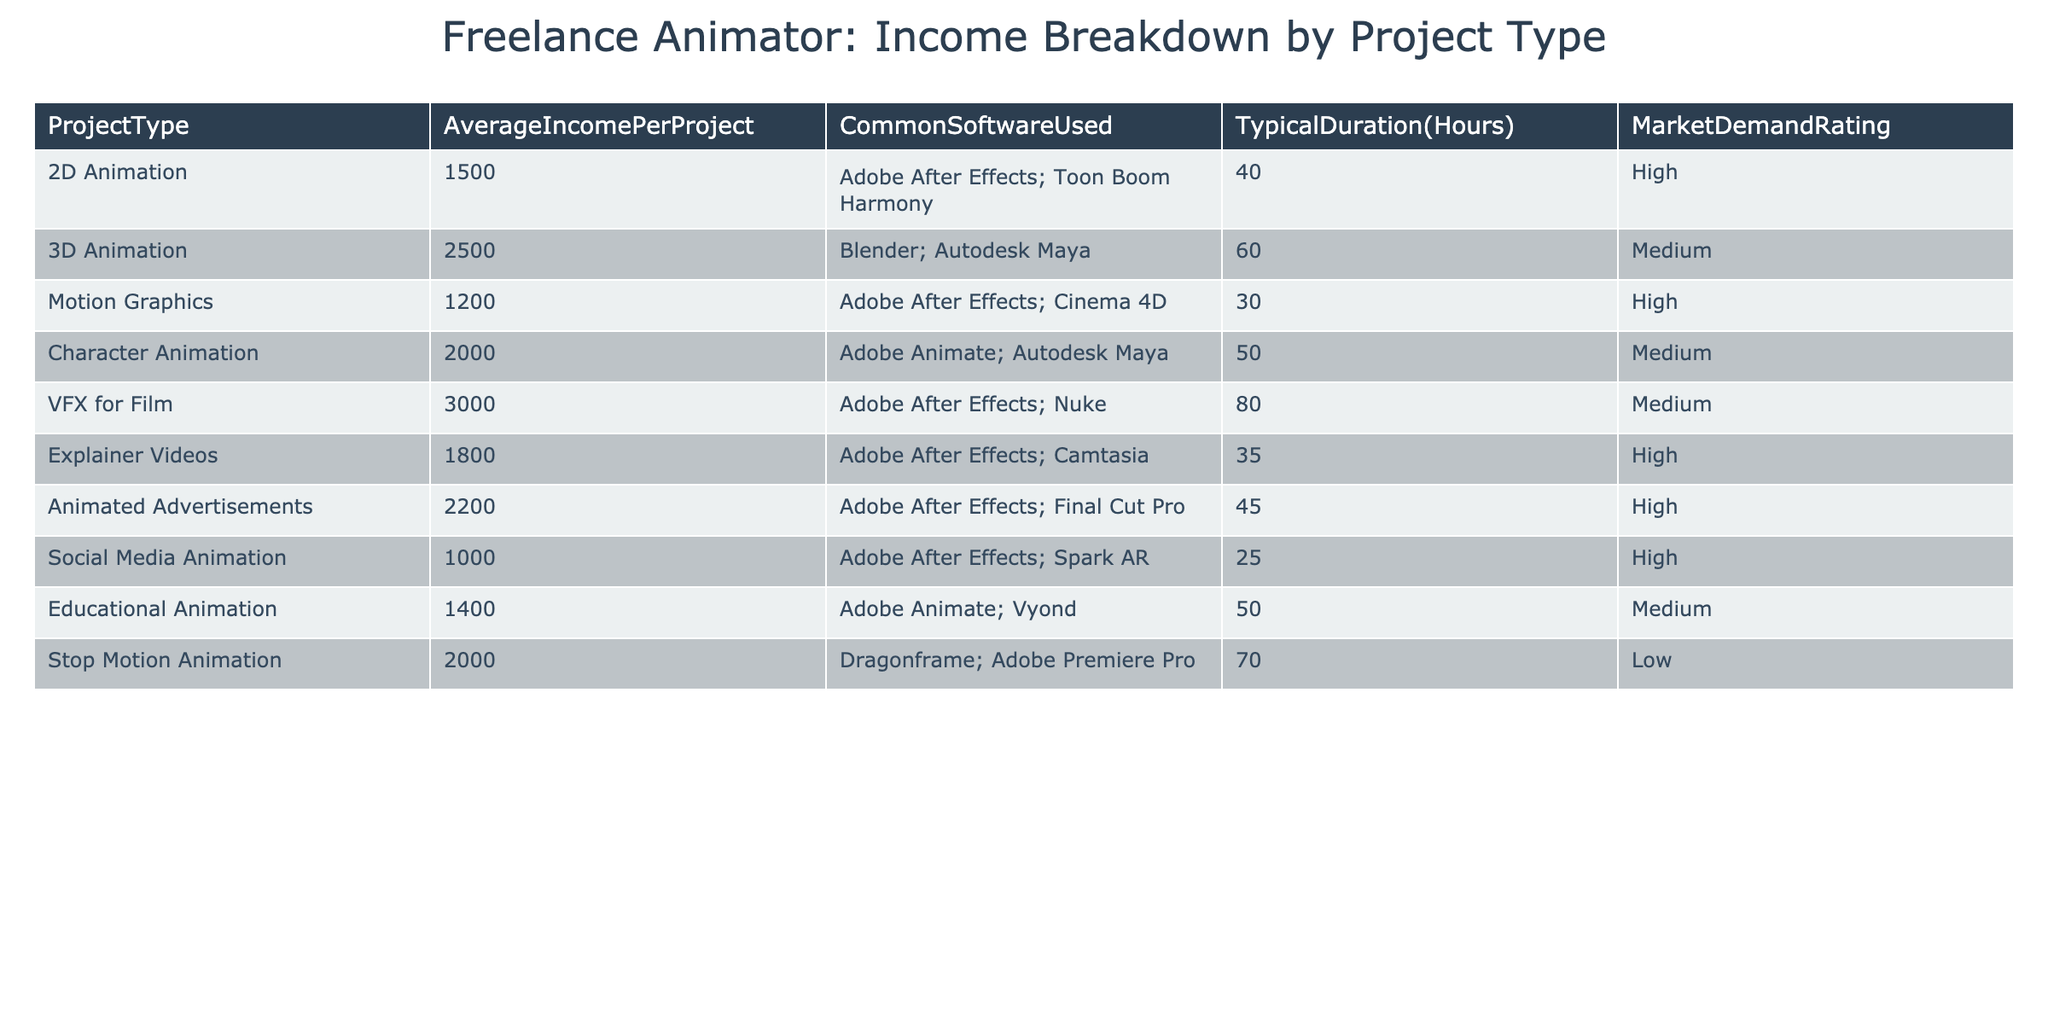What is the average income per project for 2D Animation? The table lists the average income per project for 2D Animation as 1500. This value is directly visible in the relevant row of the table.
Answer: 1500 What software is commonly used for 3D Animation? According to the table, the common software used for 3D Animation includes Blender and Autodesk Maya. These details can be found in the corresponding row of the table.
Answer: Blender; Autodesk Maya Which project type has the lowest average income per project? By examining the average income figures in the table, Social Media Animation has the lowest average income per project at 1000. I compared all average income values to confirm this.
Answer: Social Media Animation Is there a project type with a market demand rating of 'High' that earns more than 2000 on average? The table shows that Animated Advertisements (2200), VFX for Film (3000),  and Explainer Videos (1800) are the only ones with a 'High' market demand rating. Out of these, only Animated Advertisements and VFX for Film exceed 2000. Hence, the answer is yes.
Answer: Yes What is the total average income of all project types listed in the table? The total average income is calculated by adding all average incomes: 1500 + 2500 + 1200 + 2000 + 3000 + 1800 + 2200 + 1000 + 1400 + 2000 = 18600, then dividing by 10 (the total number of project types) gives us an average of 1860.
Answer: 1860 How many project types have a typical duration of more than 60 hours? In the table, VFX for Film (80 hours) and Stop Motion Animation (70 hours) are the only project types that have a typical duration exceeding 60 hours. Therefore, there are 2 such project types.
Answer: 2 Which project type has the highest market demand rating? By reviewing the table, I can see that all the project types with 'High' ratings are 2D Animation, Motion Graphics, Explainer Videos, Animated Advertisements, and Social Media Animation. However, among these, none of them has a rating higher than 'High'. Thus, the highest rating is 'High'.
Answer: High What is the difference in average income between VFX for Film and Explainer Videos? To find the difference, I subtract the average income of Explainer Videos (1800) from VFX for Film (3000). So, 3000 - 1800 = 1200. This calculation gives the required difference.
Answer: 1200 Which project type uses Dragonframe software? The table indicates that Stop Motion Animation uses Dragonframe software, which is directly mentioned in the software list for that project type.
Answer: Stop Motion Animation 